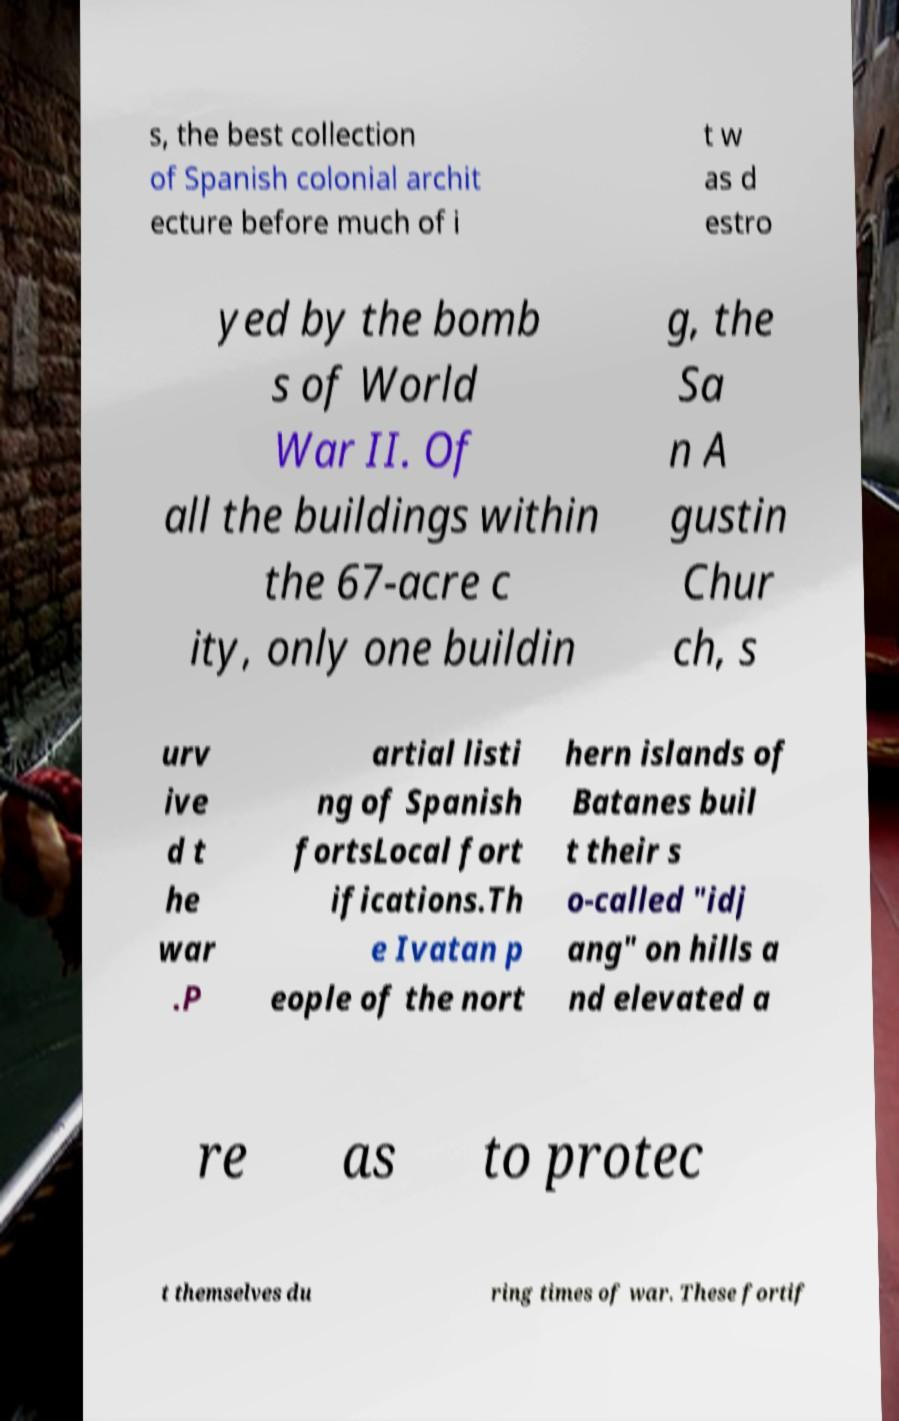Can you accurately transcribe the text from the provided image for me? s, the best collection of Spanish colonial archit ecture before much of i t w as d estro yed by the bomb s of World War II. Of all the buildings within the 67-acre c ity, only one buildin g, the Sa n A gustin Chur ch, s urv ive d t he war .P artial listi ng of Spanish fortsLocal fort ifications.Th e Ivatan p eople of the nort hern islands of Batanes buil t their s o-called "idj ang" on hills a nd elevated a re as to protec t themselves du ring times of war. These fortif 